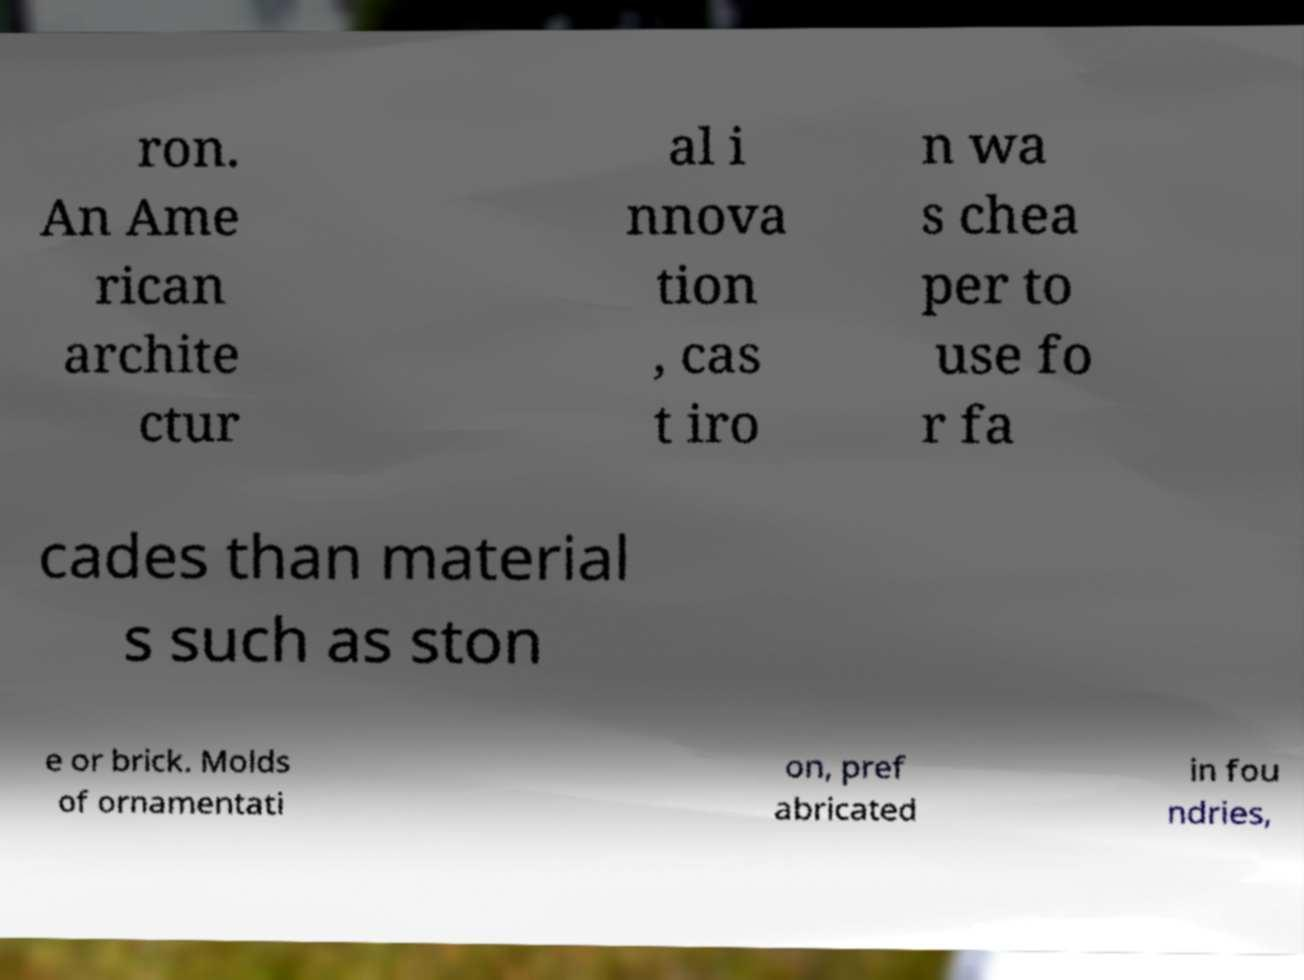Please read and relay the text visible in this image. What does it say? ron. An Ame rican archite ctur al i nnova tion , cas t iro n wa s chea per to use fo r fa cades than material s such as ston e or brick. Molds of ornamentati on, pref abricated in fou ndries, 